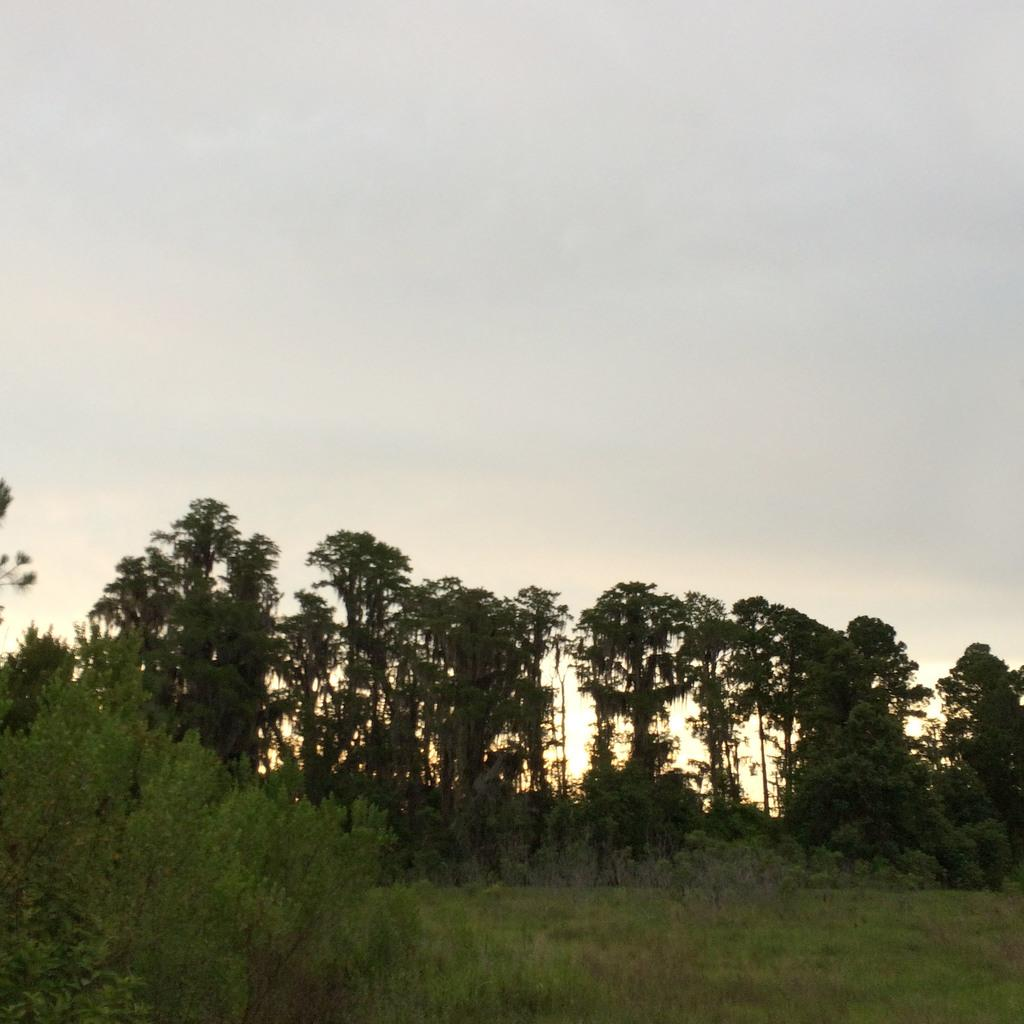What type of vegetation is in the center of the image? There are trees in the center of the image. What type of ground cover is at the bottom of the image? There is grass at the bottom of the image. What is visible at the top of the image? The sky is visible at the top of the image. What type of offer can be seen being made in the image? There is no offer being made in the image; it features trees, grass, and the sky. How many geese are flying in the image? There are no geese present in the image. 